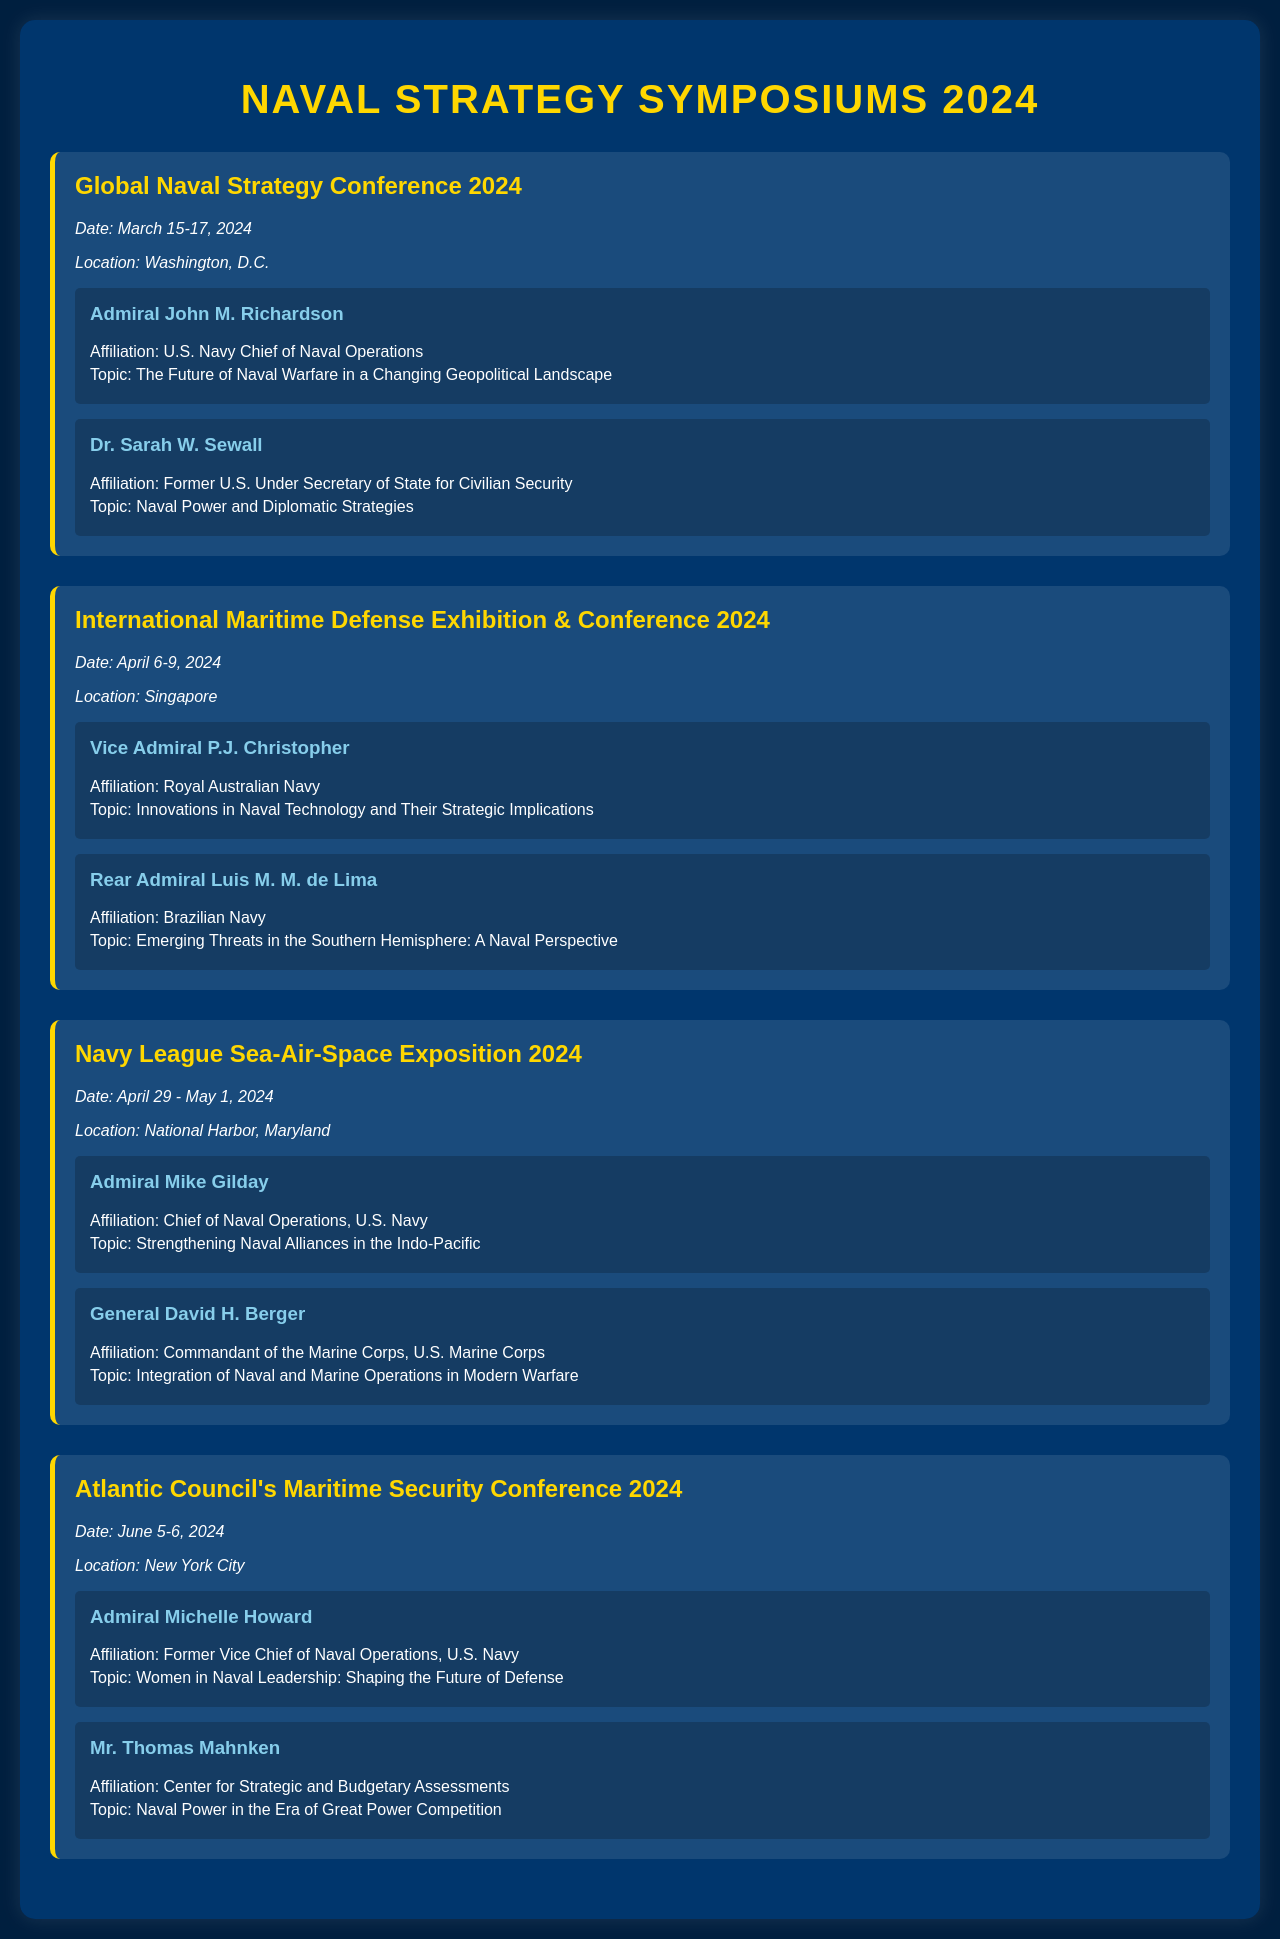What is the date of the Global Naval Strategy Conference 2024? The date is specified in the document as March 15-17, 2024.
Answer: March 15-17, 2024 Who is the speaker for the topic "Emerging Threats in the Southern Hemisphere: A Naval Perspective"? The document lists Rear Admiral Luis M. M. de Lima as the speaker for this topic.
Answer: Rear Admiral Luis M. M. de Lima What is the location of the Navy League Sea-Air-Space Exposition 2024? The document states that it will take place in National Harbor, Maryland.
Answer: National Harbor, Maryland How many symposiums are scheduled in the document? There are a total of four symposiums listed.
Answer: Four What topic does Admiral John M. Richardson address? The document highlights that he will discuss "The Future of Naval Warfare in a Changing Geopolitical Landscape."
Answer: The Future of Naval Warfare in a Changing Geopolitical Landscape Which symposium features a speaker from the Brazilian Navy? The document indicates that the International Maritime Defense Exhibition & Conference 2024 features Rear Admiral Luis M. M. de Lima from the Brazilian Navy.
Answer: International Maritime Defense Exhibition & Conference 2024 When is the Atlantic Council's Maritime Security Conference 2024 scheduled? According to the document, it is scheduled for June 5-6, 2024.
Answer: June 5-6, 2024 What is the main focus of Dr. Sarah W. Sewall's talk? The document notes that she will speak on "Naval Power and Diplomatic Strategies."
Answer: Naval Power and Diplomatic Strategies Who is the Chief of Naval Operations for the U.S. Navy mentioned in the document? The document identifies Admiral Mike Gilday as the current Chief of Naval Operations.
Answer: Admiral Mike Gilday 